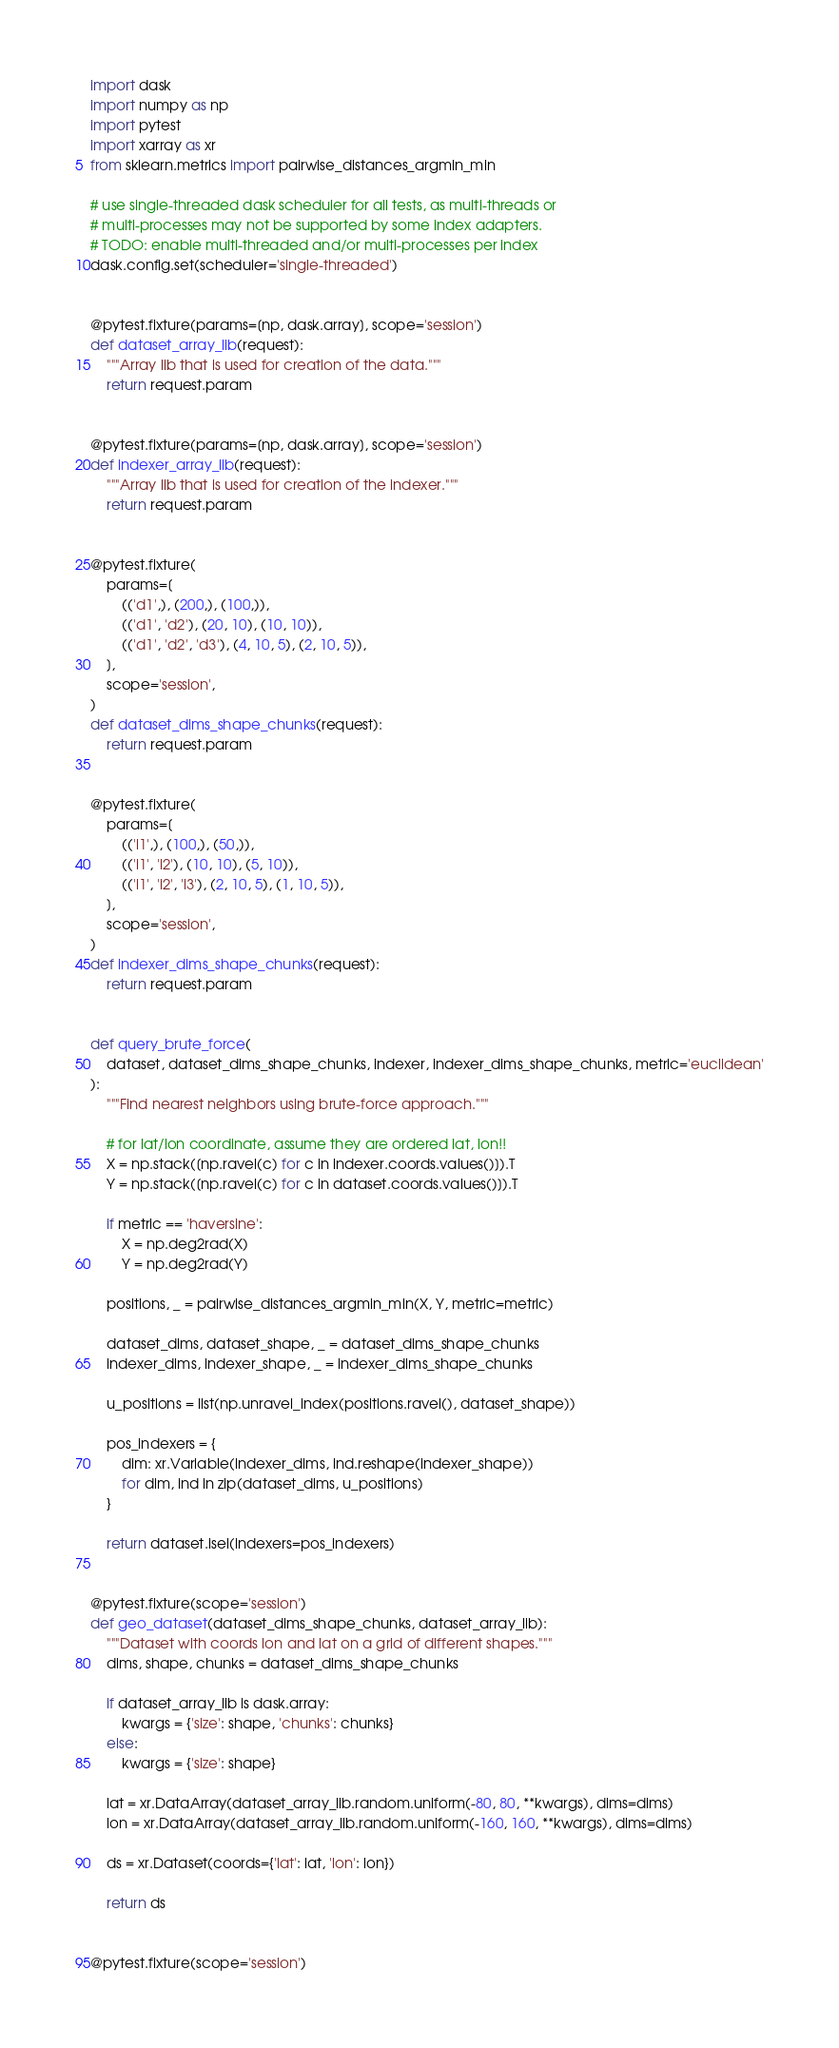<code> <loc_0><loc_0><loc_500><loc_500><_Python_>import dask
import numpy as np
import pytest
import xarray as xr
from sklearn.metrics import pairwise_distances_argmin_min

# use single-threaded dask scheduler for all tests, as multi-threads or
# multi-processes may not be supported by some index adapters.
# TODO: enable multi-threaded and/or multi-processes per index
dask.config.set(scheduler='single-threaded')


@pytest.fixture(params=[np, dask.array], scope='session')
def dataset_array_lib(request):
    """Array lib that is used for creation of the data."""
    return request.param


@pytest.fixture(params=[np, dask.array], scope='session')
def indexer_array_lib(request):
    """Array lib that is used for creation of the indexer."""
    return request.param


@pytest.fixture(
    params=[
        (('d1',), (200,), (100,)),
        (('d1', 'd2'), (20, 10), (10, 10)),
        (('d1', 'd2', 'd3'), (4, 10, 5), (2, 10, 5)),
    ],
    scope='session',
)
def dataset_dims_shape_chunks(request):
    return request.param


@pytest.fixture(
    params=[
        (('i1',), (100,), (50,)),
        (('i1', 'i2'), (10, 10), (5, 10)),
        (('i1', 'i2', 'i3'), (2, 10, 5), (1, 10, 5)),
    ],
    scope='session',
)
def indexer_dims_shape_chunks(request):
    return request.param


def query_brute_force(
    dataset, dataset_dims_shape_chunks, indexer, indexer_dims_shape_chunks, metric='euclidean'
):
    """Find nearest neighbors using brute-force approach."""

    # for lat/lon coordinate, assume they are ordered lat, lon!!
    X = np.stack([np.ravel(c) for c in indexer.coords.values()]).T
    Y = np.stack([np.ravel(c) for c in dataset.coords.values()]).T

    if metric == 'haversine':
        X = np.deg2rad(X)
        Y = np.deg2rad(Y)

    positions, _ = pairwise_distances_argmin_min(X, Y, metric=metric)

    dataset_dims, dataset_shape, _ = dataset_dims_shape_chunks
    indexer_dims, indexer_shape, _ = indexer_dims_shape_chunks

    u_positions = list(np.unravel_index(positions.ravel(), dataset_shape))

    pos_indexers = {
        dim: xr.Variable(indexer_dims, ind.reshape(indexer_shape))
        for dim, ind in zip(dataset_dims, u_positions)
    }

    return dataset.isel(indexers=pos_indexers)


@pytest.fixture(scope='session')
def geo_dataset(dataset_dims_shape_chunks, dataset_array_lib):
    """Dataset with coords lon and lat on a grid of different shapes."""
    dims, shape, chunks = dataset_dims_shape_chunks

    if dataset_array_lib is dask.array:
        kwargs = {'size': shape, 'chunks': chunks}
    else:
        kwargs = {'size': shape}

    lat = xr.DataArray(dataset_array_lib.random.uniform(-80, 80, **kwargs), dims=dims)
    lon = xr.DataArray(dataset_array_lib.random.uniform(-160, 160, **kwargs), dims=dims)

    ds = xr.Dataset(coords={'lat': lat, 'lon': lon})

    return ds


@pytest.fixture(scope='session')</code> 